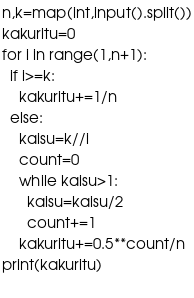Convert code to text. <code><loc_0><loc_0><loc_500><loc_500><_Python_>n,k=map(int,input().split())
kakuritu=0
for i in range(1,n+1):
  if i>=k:
    kakuritu+=1/n
  else:
    kaisu=k//i
    count=0
    while kaisu>1:
      kaisu=kaisu/2
      count+=1
    kakuritu+=0.5**count/n
print(kakuritu)
      
</code> 